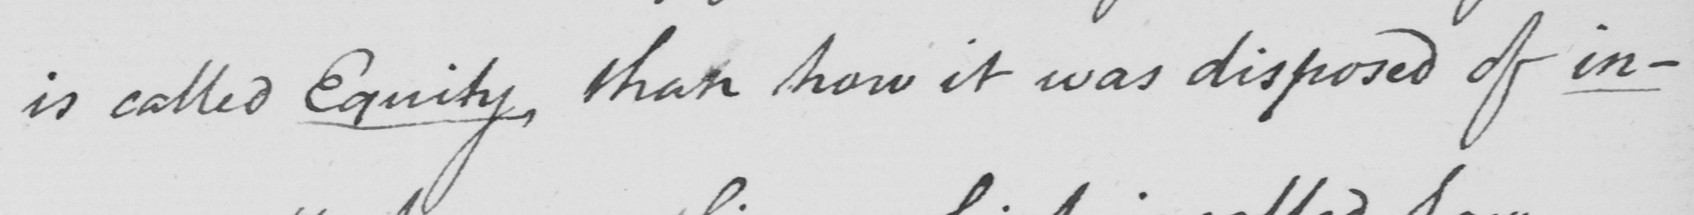Please transcribe the handwritten text in this image. is called Equity , than how it was disposed of in- 